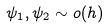<formula> <loc_0><loc_0><loc_500><loc_500>\psi _ { 1 } , \psi _ { 2 } \sim o ( h )</formula> 